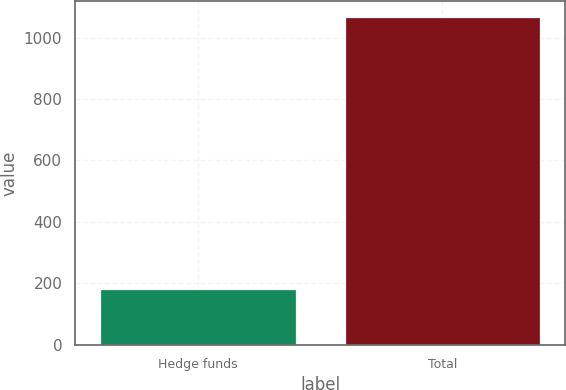<chart> <loc_0><loc_0><loc_500><loc_500><bar_chart><fcel>Hedge funds<fcel>Total<nl><fcel>183<fcel>1066<nl></chart> 